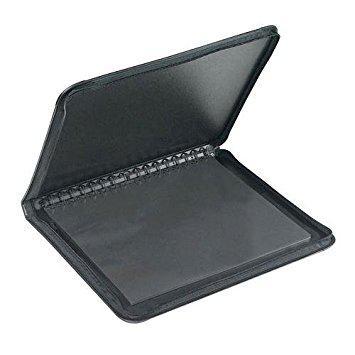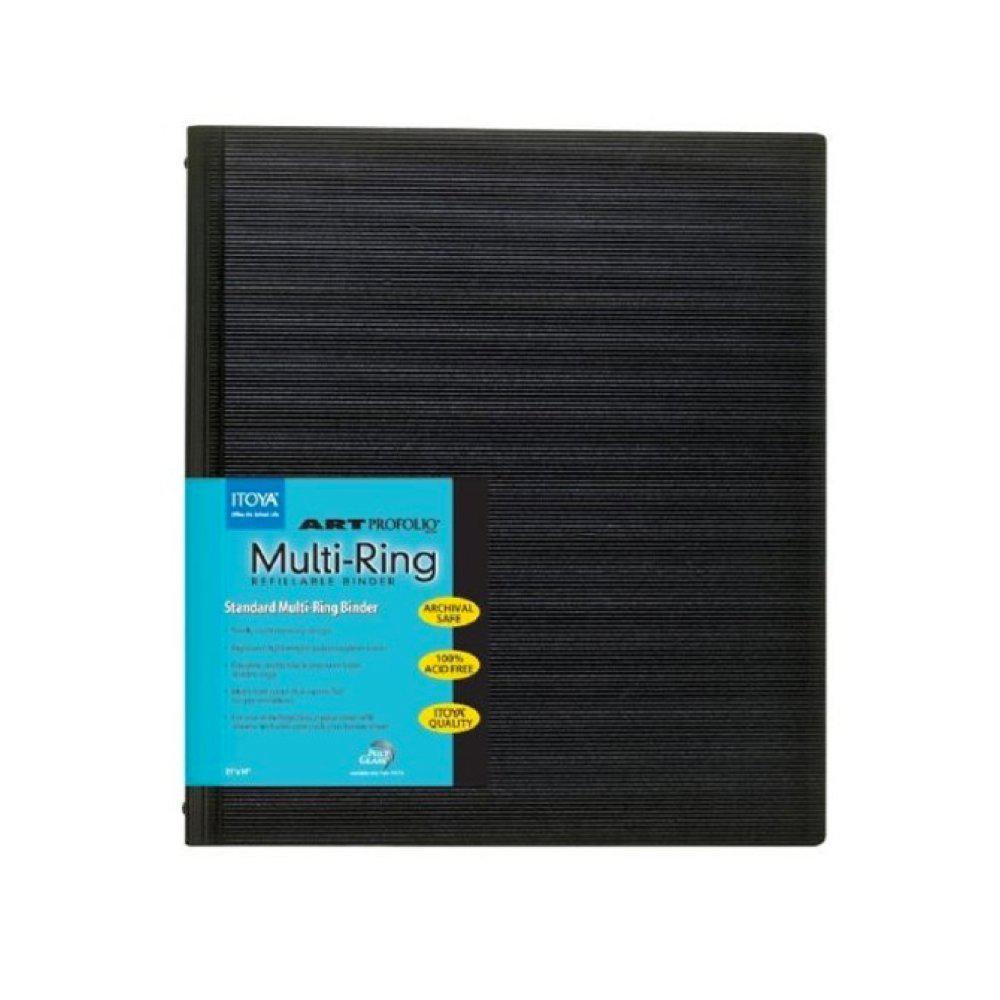The first image is the image on the left, the second image is the image on the right. Examine the images to the left and right. Is the description "One photo features a single closed binder with a brand label on the front." accurate? Answer yes or no. Yes. The first image is the image on the left, the second image is the image on the right. Evaluate the accuracy of this statement regarding the images: "An image shows one closed black binder with a colored label on the front.". Is it true? Answer yes or no. Yes. 